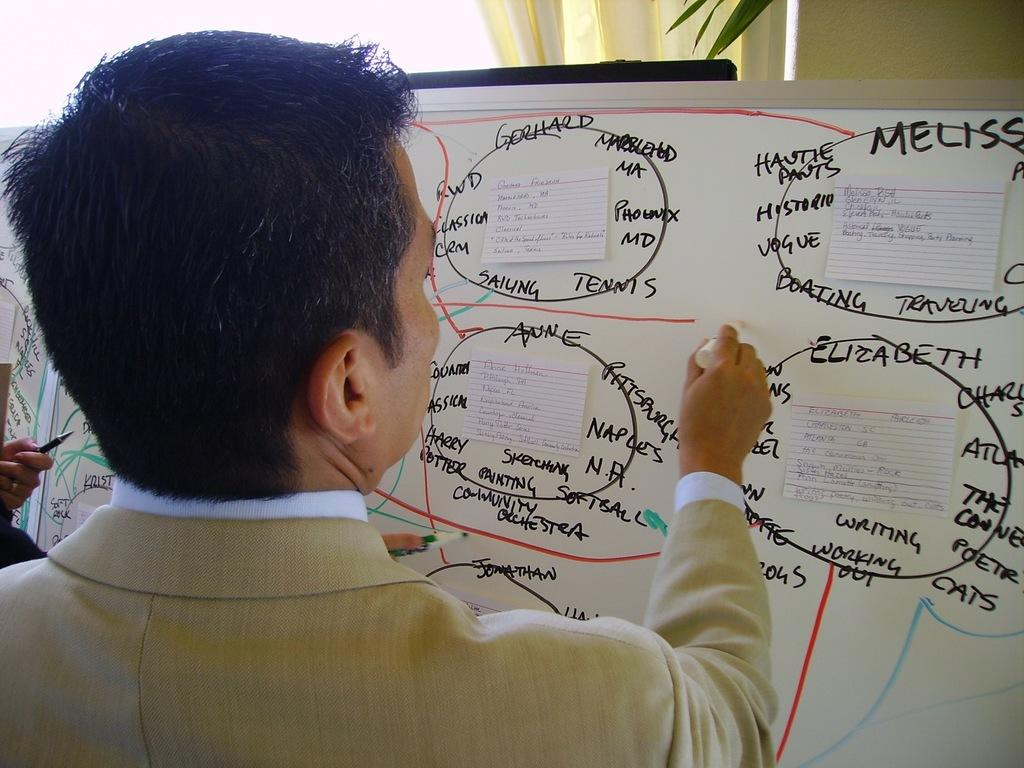Provide a one-sentence caption for the provided image. Several names, including "Elizabeth" are written on a white board. 